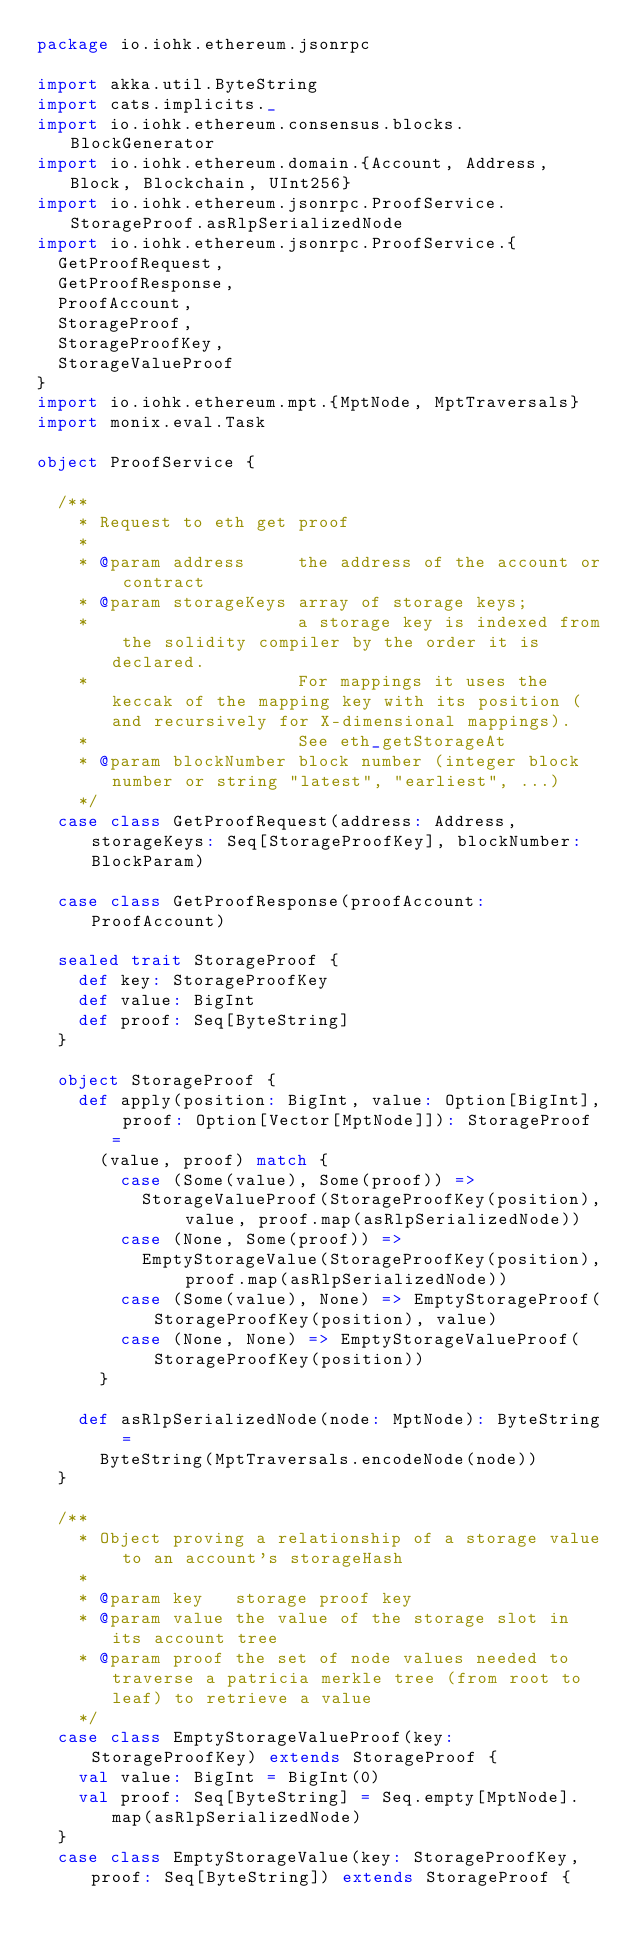<code> <loc_0><loc_0><loc_500><loc_500><_Scala_>package io.iohk.ethereum.jsonrpc

import akka.util.ByteString
import cats.implicits._
import io.iohk.ethereum.consensus.blocks.BlockGenerator
import io.iohk.ethereum.domain.{Account, Address, Block, Blockchain, UInt256}
import io.iohk.ethereum.jsonrpc.ProofService.StorageProof.asRlpSerializedNode
import io.iohk.ethereum.jsonrpc.ProofService.{
  GetProofRequest,
  GetProofResponse,
  ProofAccount,
  StorageProof,
  StorageProofKey,
  StorageValueProof
}
import io.iohk.ethereum.mpt.{MptNode, MptTraversals}
import monix.eval.Task

object ProofService {

  /**
    * Request to eth get proof
    *
    * @param address     the address of the account or contract
    * @param storageKeys array of storage keys;
    *                    a storage key is indexed from the solidity compiler by the order it is declared.
    *                    For mappings it uses the keccak of the mapping key with its position (and recursively for X-dimensional mappings).
    *                    See eth_getStorageAt
    * @param blockNumber block number (integer block number or string "latest", "earliest", ...)
    */
  case class GetProofRequest(address: Address, storageKeys: Seq[StorageProofKey], blockNumber: BlockParam)

  case class GetProofResponse(proofAccount: ProofAccount)

  sealed trait StorageProof {
    def key: StorageProofKey
    def value: BigInt
    def proof: Seq[ByteString]
  }

  object StorageProof {
    def apply(position: BigInt, value: Option[BigInt], proof: Option[Vector[MptNode]]): StorageProof =
      (value, proof) match {
        case (Some(value), Some(proof)) =>
          StorageValueProof(StorageProofKey(position), value, proof.map(asRlpSerializedNode))
        case (None, Some(proof)) =>
          EmptyStorageValue(StorageProofKey(position), proof.map(asRlpSerializedNode))
        case (Some(value), None) => EmptyStorageProof(StorageProofKey(position), value)
        case (None, None) => EmptyStorageValueProof(StorageProofKey(position))
      }

    def asRlpSerializedNode(node: MptNode): ByteString =
      ByteString(MptTraversals.encodeNode(node))
  }

  /**
    * Object proving a relationship of a storage value to an account's storageHash
    *
    * @param key   storage proof key
    * @param value the value of the storage slot in its account tree
    * @param proof the set of node values needed to traverse a patricia merkle tree (from root to leaf) to retrieve a value
    */
  case class EmptyStorageValueProof(key: StorageProofKey) extends StorageProof {
    val value: BigInt = BigInt(0)
    val proof: Seq[ByteString] = Seq.empty[MptNode].map(asRlpSerializedNode)
  }
  case class EmptyStorageValue(key: StorageProofKey, proof: Seq[ByteString]) extends StorageProof {</code> 